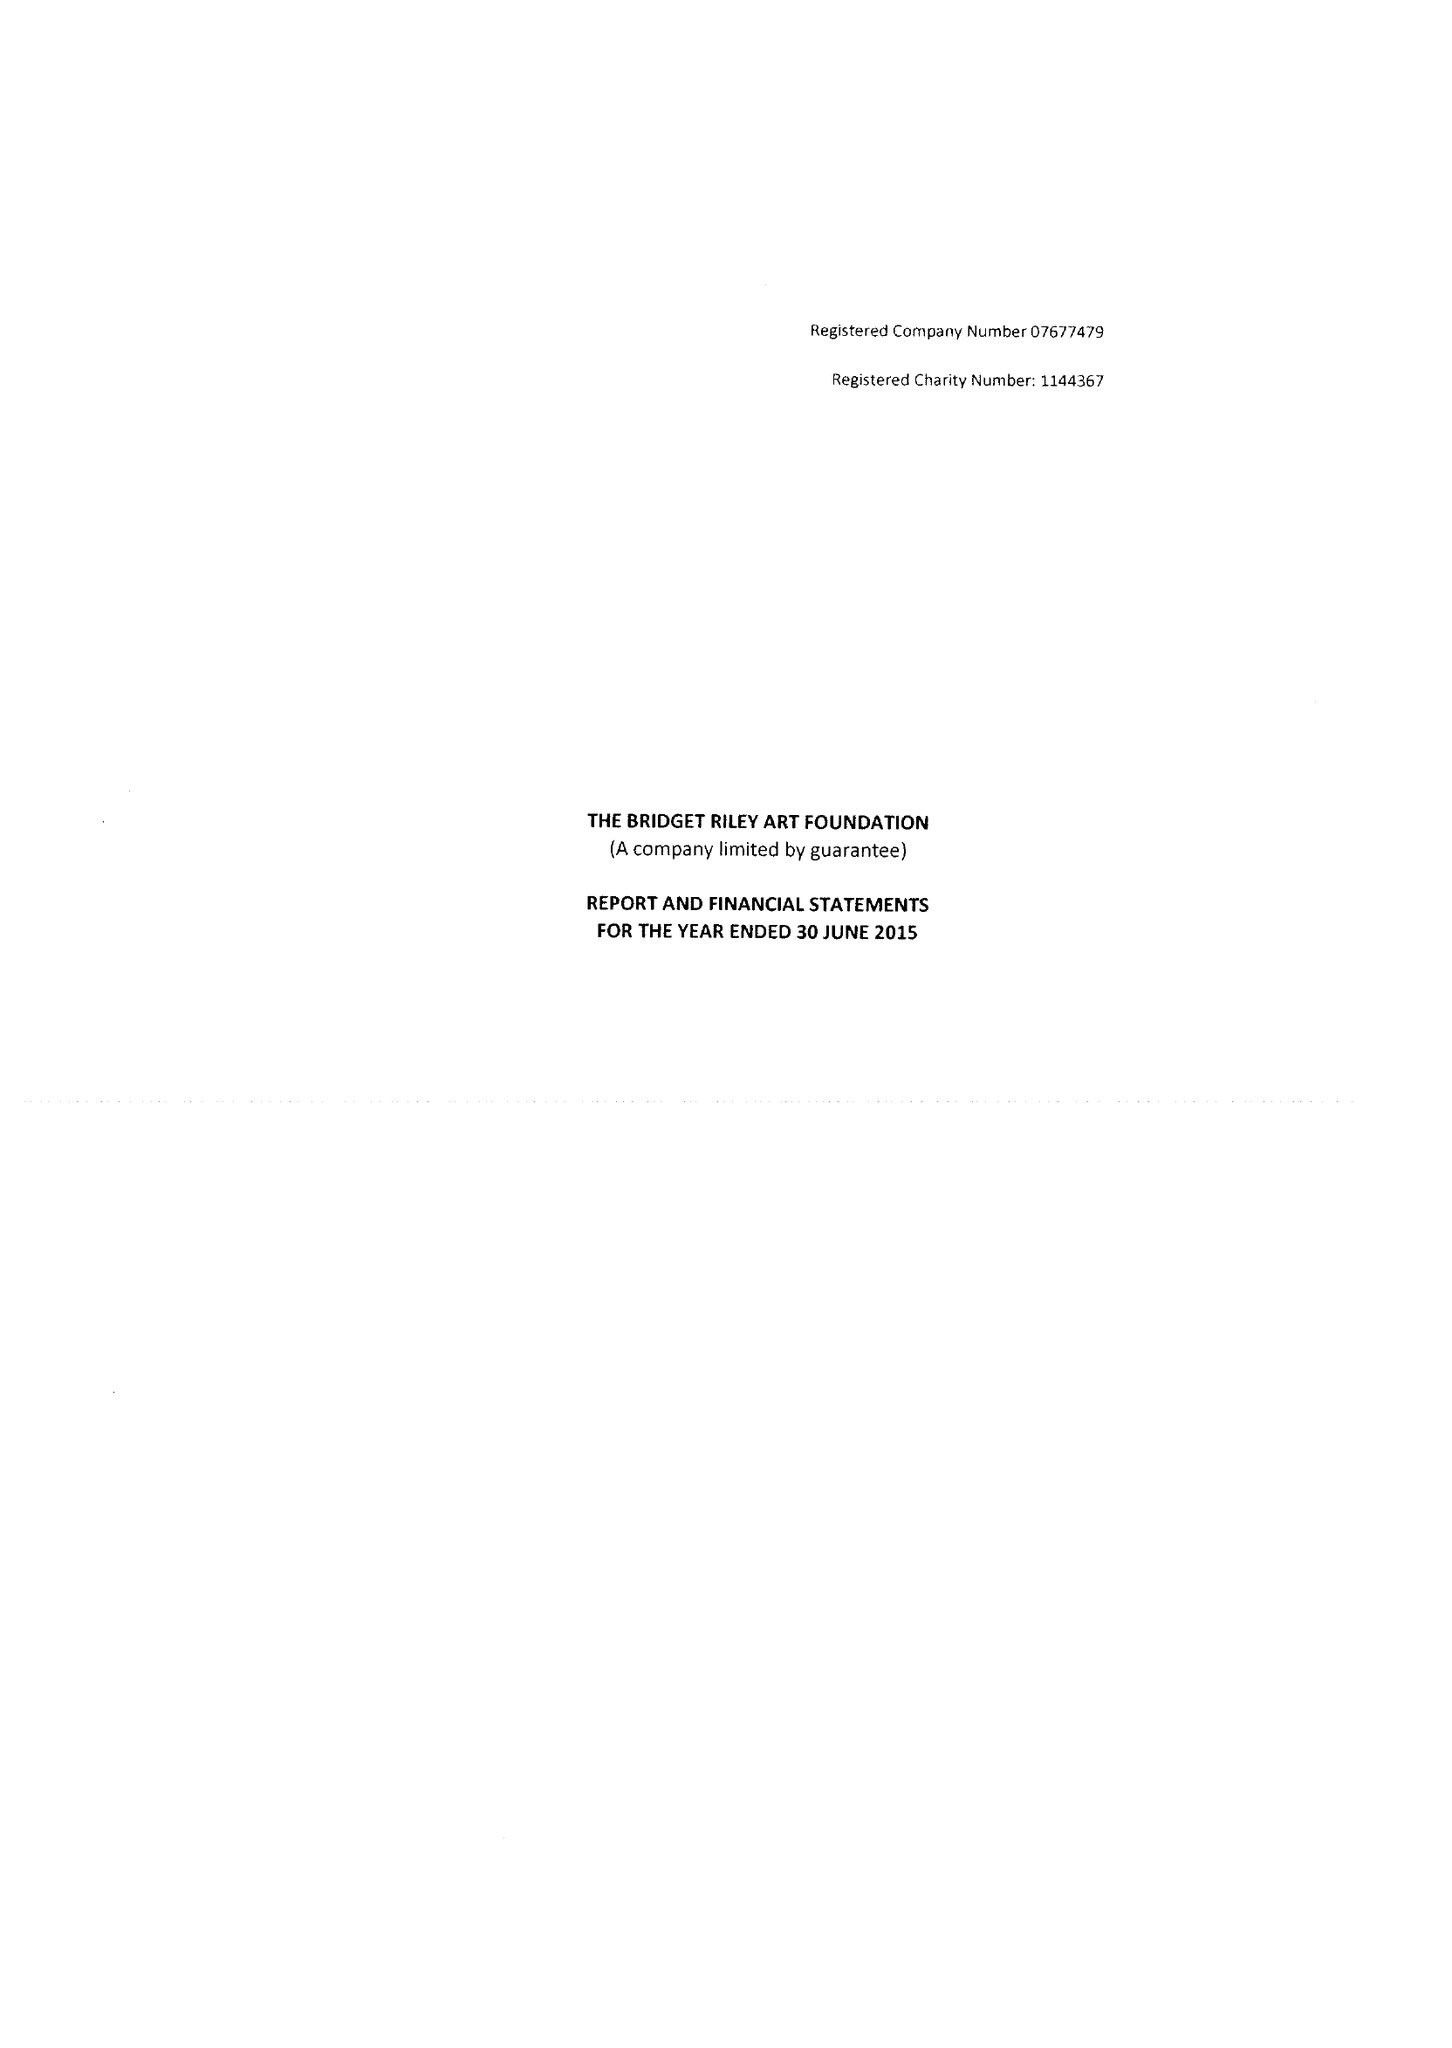What is the value for the charity_name?
Answer the question using a single word or phrase. The Bridget Riley Art Foundation 